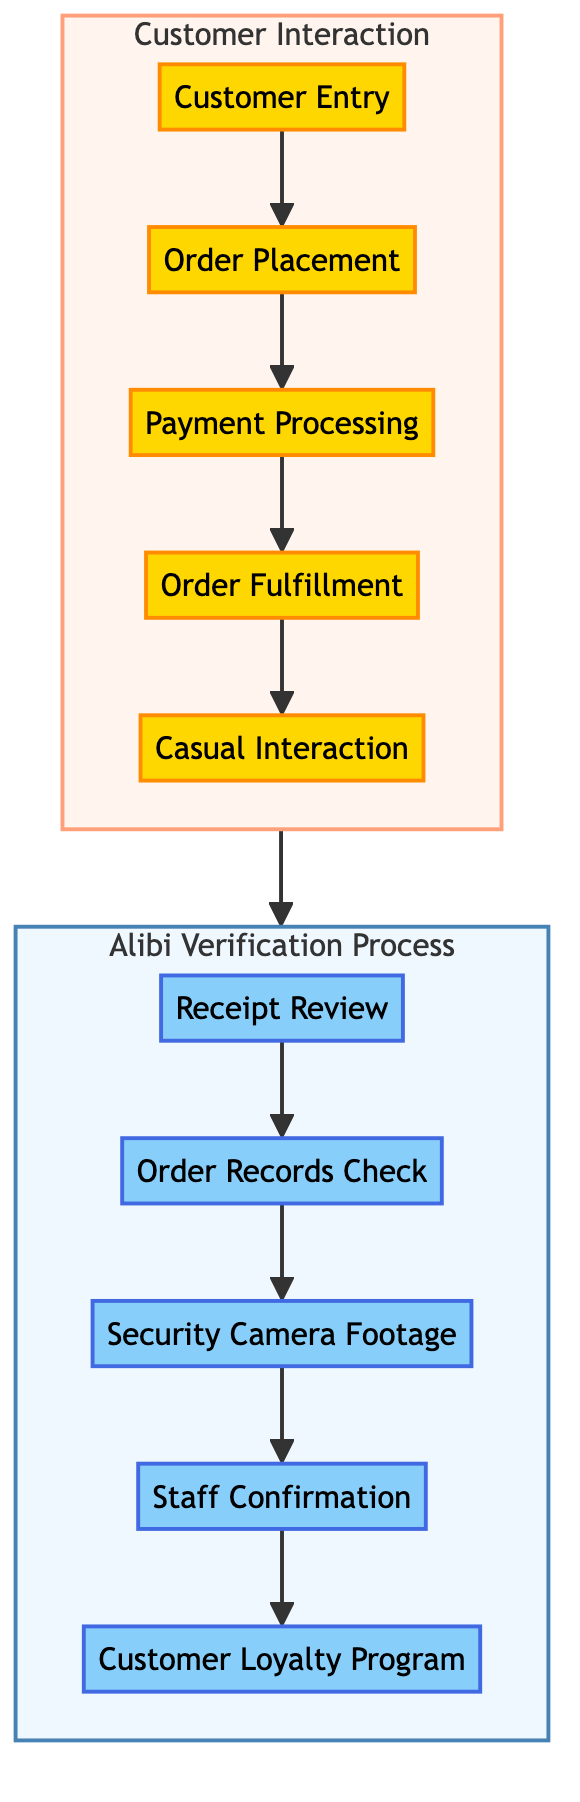What is the first step in the Customer Interaction? The first step listed in the diagram under the Customer Interaction section is "Customer Entry," where the customer walks into the bakery and is greeted.
Answer: Customer Entry How many steps are there in the Alibi Verification process? The Alibi Verification process contains five distinct steps: Receipt Review, Order Records Check, Security Camera Footage, Staff Confirmation, and Customer Loyalty Program.
Answer: Five What follows "Order Placement" in the Customer Interaction? The step following "Order Placement" in the diagram is "Payment Processing," indicating the sequence of actions in the interaction.
Answer: Payment Processing What is the last step in the Alibi Verification process? The last step outlined in the Alibi Verification is "Customer Loyalty Program," which suggests additional verification measures if applicable.
Answer: Customer Loyalty Program Which step in Customer Interaction involves engaging with the customer? The step that involves engaging with the customer during the Customer Interaction is "Casual Interaction," where friendly conversation takes place, and observations are noted.
Answer: Casual Interaction What connects Customer Interaction to Alibi Verification in the diagram? The connection between Customer Interaction and Alibi Verification is a directed flow that indicates a sequence where the outcome of the customer interaction leads to the alibi verification process.
Answer: Directed flow What step in Alibi Verification involves visual evidence? The step that involves visual evidence is "Security Camera Footage," where CCTV footage is reviewed to verify the customer’s presence and activities.
Answer: Security Camera Footage How is customer payment handled in the process? Customer payment is handled through the "Payment Processing" step, where the customer makes a payment and receives a receipt for their order.
Answer: Payment Processing Which step is characterized by checking order details in the order management system? The step characterized by checking order details is "Order Records Check," which verifies the specifics of the order including time stamps.
Answer: Order Records Check 